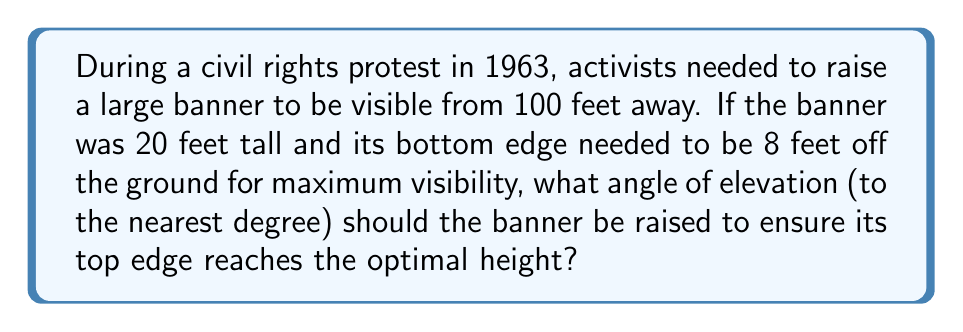Can you answer this question? Let's approach this step-by-step:

1) First, let's visualize the problem:

[asy]
import geometry;

unitsize(2mm);

pair A = (0,0), B = (100,0), C = (0,8), D = (0,28);
draw(A--B--D--A);
draw(C--D);
label("Ground", (50,-2));
label("100 ft", (50,2));
label("8 ft", (-2,4));
label("20 ft", (-2,18));
label("Banner", (2,18), E);
label("θ", (5,1), NW);

draw(arc(A,5,0,atan2(28,100)*180/pi), Arrow);
[/asy]

2) We need to find the angle θ between the ground and the line of sight to the top of the banner.

3) We can use the tangent function to find this angle:

   $$\tan(\theta) = \frac{\text{opposite}}{\text{adjacent}} = \frac{\text{height of banner top}}{\text{distance}}$$

4) The height of the banner top is the sum of the ground clearance and the banner height:
   8 ft + 20 ft = 28 ft

5) Now we can set up our equation:

   $$\tan(\theta) = \frac{28}{100}$$

6) To solve for θ, we need to use the inverse tangent (arctan) function:

   $$\theta = \arctan(\frac{28}{100})$$

7) Using a calculator or computer:

   $$\theta \approx 15.64^\circ$$

8) Rounding to the nearest degree:

   $$\theta \approx 16^\circ$$
Answer: $16^\circ$ 